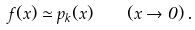Convert formula to latex. <formula><loc_0><loc_0><loc_500><loc_500>f ( x ) \simeq p _ { k } ( x ) \quad ( x \rightarrow 0 ) \, .</formula> 